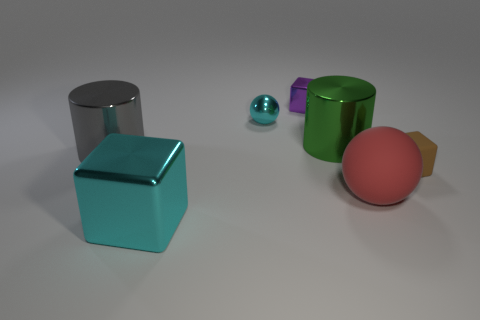How many objects are big cylinders in front of the green metallic cylinder or cyan things that are behind the red rubber ball?
Make the answer very short. 2. Are there an equal number of large red matte spheres that are on the right side of the tiny brown object and green metal cylinders?
Give a very brief answer. No. There is a block left of the small purple object; does it have the same size as the cylinder to the left of the purple object?
Offer a very short reply. Yes. What number of other things are the same size as the matte sphere?
Your response must be concise. 3. There is a cyan shiny thing right of the object in front of the red sphere; is there a tiny brown block behind it?
Your answer should be very brief. No. Is there anything else of the same color as the big matte ball?
Provide a short and direct response. No. There is a cube that is to the right of the tiny purple block; how big is it?
Your answer should be very brief. Small. There is a cylinder that is on the left side of the ball that is on the left side of the tiny cube behind the green metallic cylinder; what size is it?
Your answer should be very brief. Large. The small thing that is right of the metal cube that is behind the tiny brown rubber object is what color?
Give a very brief answer. Brown. What material is the tiny purple thing that is the same shape as the tiny brown thing?
Your response must be concise. Metal. 